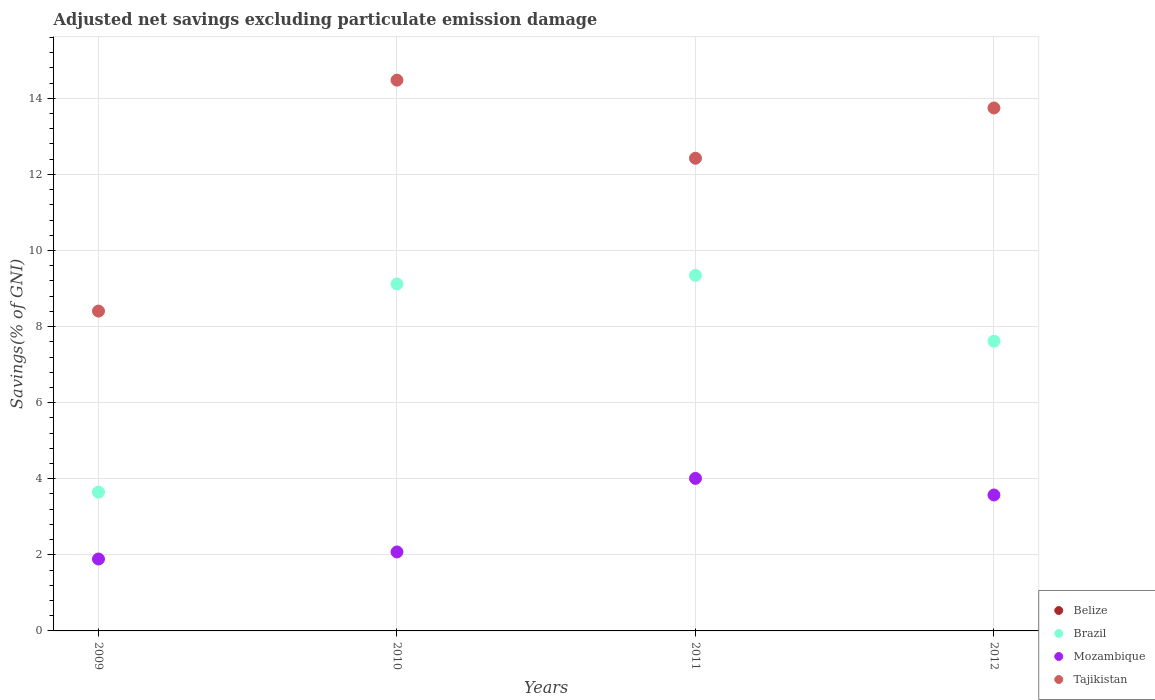How many different coloured dotlines are there?
Offer a terse response. 3. Is the number of dotlines equal to the number of legend labels?
Provide a succinct answer. No. Across all years, what is the maximum adjusted net savings in Tajikistan?
Provide a short and direct response. 14.48. Across all years, what is the minimum adjusted net savings in Mozambique?
Keep it short and to the point. 1.89. In which year was the adjusted net savings in Brazil maximum?
Your answer should be very brief. 2011. What is the total adjusted net savings in Belize in the graph?
Offer a terse response. 0. What is the difference between the adjusted net savings in Mozambique in 2010 and that in 2011?
Offer a terse response. -1.93. What is the difference between the adjusted net savings in Tajikistan in 2011 and the adjusted net savings in Brazil in 2010?
Make the answer very short. 3.3. What is the average adjusted net savings in Tajikistan per year?
Keep it short and to the point. 12.26. In the year 2012, what is the difference between the adjusted net savings in Tajikistan and adjusted net savings in Brazil?
Your answer should be very brief. 6.13. What is the ratio of the adjusted net savings in Brazil in 2010 to that in 2012?
Ensure brevity in your answer.  1.2. What is the difference between the highest and the second highest adjusted net savings in Mozambique?
Provide a short and direct response. 0.44. What is the difference between the highest and the lowest adjusted net savings in Tajikistan?
Offer a very short reply. 6.07. In how many years, is the adjusted net savings in Mozambique greater than the average adjusted net savings in Mozambique taken over all years?
Provide a short and direct response. 2. Is the sum of the adjusted net savings in Brazil in 2010 and 2012 greater than the maximum adjusted net savings in Belize across all years?
Provide a short and direct response. Yes. Is it the case that in every year, the sum of the adjusted net savings in Brazil and adjusted net savings in Mozambique  is greater than the adjusted net savings in Belize?
Offer a terse response. Yes. Is the adjusted net savings in Tajikistan strictly greater than the adjusted net savings in Brazil over the years?
Offer a terse response. Yes. Is the adjusted net savings in Tajikistan strictly less than the adjusted net savings in Brazil over the years?
Provide a short and direct response. No. How many dotlines are there?
Provide a succinct answer. 3. What is the difference between two consecutive major ticks on the Y-axis?
Offer a very short reply. 2. Are the values on the major ticks of Y-axis written in scientific E-notation?
Offer a very short reply. No. Does the graph contain grids?
Make the answer very short. Yes. Where does the legend appear in the graph?
Give a very brief answer. Bottom right. How are the legend labels stacked?
Offer a very short reply. Vertical. What is the title of the graph?
Your response must be concise. Adjusted net savings excluding particulate emission damage. What is the label or title of the Y-axis?
Ensure brevity in your answer.  Savings(% of GNI). What is the Savings(% of GNI) in Brazil in 2009?
Offer a terse response. 3.65. What is the Savings(% of GNI) of Mozambique in 2009?
Make the answer very short. 1.89. What is the Savings(% of GNI) in Tajikistan in 2009?
Your answer should be compact. 8.41. What is the Savings(% of GNI) in Belize in 2010?
Ensure brevity in your answer.  0. What is the Savings(% of GNI) in Brazil in 2010?
Your answer should be compact. 9.12. What is the Savings(% of GNI) of Mozambique in 2010?
Your response must be concise. 2.08. What is the Savings(% of GNI) in Tajikistan in 2010?
Provide a short and direct response. 14.48. What is the Savings(% of GNI) of Brazil in 2011?
Your answer should be very brief. 9.35. What is the Savings(% of GNI) in Mozambique in 2011?
Offer a terse response. 4.01. What is the Savings(% of GNI) in Tajikistan in 2011?
Your response must be concise. 12.42. What is the Savings(% of GNI) in Belize in 2012?
Give a very brief answer. 0. What is the Savings(% of GNI) in Brazil in 2012?
Provide a short and direct response. 7.62. What is the Savings(% of GNI) in Mozambique in 2012?
Ensure brevity in your answer.  3.57. What is the Savings(% of GNI) in Tajikistan in 2012?
Your response must be concise. 13.75. Across all years, what is the maximum Savings(% of GNI) in Brazil?
Keep it short and to the point. 9.35. Across all years, what is the maximum Savings(% of GNI) of Mozambique?
Provide a succinct answer. 4.01. Across all years, what is the maximum Savings(% of GNI) in Tajikistan?
Offer a terse response. 14.48. Across all years, what is the minimum Savings(% of GNI) of Brazil?
Offer a terse response. 3.65. Across all years, what is the minimum Savings(% of GNI) of Mozambique?
Offer a very short reply. 1.89. Across all years, what is the minimum Savings(% of GNI) in Tajikistan?
Your answer should be very brief. 8.41. What is the total Savings(% of GNI) in Belize in the graph?
Provide a succinct answer. 0. What is the total Savings(% of GNI) in Brazil in the graph?
Give a very brief answer. 29.73. What is the total Savings(% of GNI) in Mozambique in the graph?
Offer a terse response. 11.55. What is the total Savings(% of GNI) in Tajikistan in the graph?
Provide a short and direct response. 49.06. What is the difference between the Savings(% of GNI) in Brazil in 2009 and that in 2010?
Provide a short and direct response. -5.47. What is the difference between the Savings(% of GNI) in Mozambique in 2009 and that in 2010?
Give a very brief answer. -0.19. What is the difference between the Savings(% of GNI) of Tajikistan in 2009 and that in 2010?
Give a very brief answer. -6.07. What is the difference between the Savings(% of GNI) in Brazil in 2009 and that in 2011?
Ensure brevity in your answer.  -5.7. What is the difference between the Savings(% of GNI) in Mozambique in 2009 and that in 2011?
Offer a very short reply. -2.12. What is the difference between the Savings(% of GNI) of Tajikistan in 2009 and that in 2011?
Give a very brief answer. -4.02. What is the difference between the Savings(% of GNI) in Brazil in 2009 and that in 2012?
Your answer should be very brief. -3.97. What is the difference between the Savings(% of GNI) in Mozambique in 2009 and that in 2012?
Ensure brevity in your answer.  -1.68. What is the difference between the Savings(% of GNI) in Tajikistan in 2009 and that in 2012?
Your response must be concise. -5.34. What is the difference between the Savings(% of GNI) of Brazil in 2010 and that in 2011?
Offer a very short reply. -0.23. What is the difference between the Savings(% of GNI) of Mozambique in 2010 and that in 2011?
Provide a succinct answer. -1.93. What is the difference between the Savings(% of GNI) in Tajikistan in 2010 and that in 2011?
Keep it short and to the point. 2.05. What is the difference between the Savings(% of GNI) in Brazil in 2010 and that in 2012?
Make the answer very short. 1.51. What is the difference between the Savings(% of GNI) of Mozambique in 2010 and that in 2012?
Your response must be concise. -1.5. What is the difference between the Savings(% of GNI) of Tajikistan in 2010 and that in 2012?
Offer a very short reply. 0.73. What is the difference between the Savings(% of GNI) of Brazil in 2011 and that in 2012?
Provide a short and direct response. 1.73. What is the difference between the Savings(% of GNI) in Mozambique in 2011 and that in 2012?
Your response must be concise. 0.44. What is the difference between the Savings(% of GNI) of Tajikistan in 2011 and that in 2012?
Give a very brief answer. -1.32. What is the difference between the Savings(% of GNI) of Brazil in 2009 and the Savings(% of GNI) of Mozambique in 2010?
Your answer should be compact. 1.57. What is the difference between the Savings(% of GNI) in Brazil in 2009 and the Savings(% of GNI) in Tajikistan in 2010?
Keep it short and to the point. -10.83. What is the difference between the Savings(% of GNI) of Mozambique in 2009 and the Savings(% of GNI) of Tajikistan in 2010?
Your answer should be very brief. -12.59. What is the difference between the Savings(% of GNI) in Brazil in 2009 and the Savings(% of GNI) in Mozambique in 2011?
Offer a very short reply. -0.36. What is the difference between the Savings(% of GNI) in Brazil in 2009 and the Savings(% of GNI) in Tajikistan in 2011?
Your response must be concise. -8.78. What is the difference between the Savings(% of GNI) in Mozambique in 2009 and the Savings(% of GNI) in Tajikistan in 2011?
Offer a very short reply. -10.53. What is the difference between the Savings(% of GNI) in Brazil in 2009 and the Savings(% of GNI) in Mozambique in 2012?
Offer a terse response. 0.07. What is the difference between the Savings(% of GNI) in Brazil in 2009 and the Savings(% of GNI) in Tajikistan in 2012?
Make the answer very short. -10.1. What is the difference between the Savings(% of GNI) of Mozambique in 2009 and the Savings(% of GNI) of Tajikistan in 2012?
Provide a succinct answer. -11.86. What is the difference between the Savings(% of GNI) in Brazil in 2010 and the Savings(% of GNI) in Mozambique in 2011?
Offer a very short reply. 5.11. What is the difference between the Savings(% of GNI) in Brazil in 2010 and the Savings(% of GNI) in Tajikistan in 2011?
Your response must be concise. -3.3. What is the difference between the Savings(% of GNI) of Mozambique in 2010 and the Savings(% of GNI) of Tajikistan in 2011?
Provide a succinct answer. -10.35. What is the difference between the Savings(% of GNI) of Brazil in 2010 and the Savings(% of GNI) of Mozambique in 2012?
Your answer should be compact. 5.55. What is the difference between the Savings(% of GNI) of Brazil in 2010 and the Savings(% of GNI) of Tajikistan in 2012?
Make the answer very short. -4.63. What is the difference between the Savings(% of GNI) in Mozambique in 2010 and the Savings(% of GNI) in Tajikistan in 2012?
Your answer should be compact. -11.67. What is the difference between the Savings(% of GNI) of Brazil in 2011 and the Savings(% of GNI) of Mozambique in 2012?
Ensure brevity in your answer.  5.77. What is the difference between the Savings(% of GNI) in Brazil in 2011 and the Savings(% of GNI) in Tajikistan in 2012?
Your response must be concise. -4.4. What is the difference between the Savings(% of GNI) of Mozambique in 2011 and the Savings(% of GNI) of Tajikistan in 2012?
Give a very brief answer. -9.74. What is the average Savings(% of GNI) in Brazil per year?
Provide a succinct answer. 7.43. What is the average Savings(% of GNI) in Mozambique per year?
Offer a terse response. 2.89. What is the average Savings(% of GNI) of Tajikistan per year?
Your answer should be compact. 12.26. In the year 2009, what is the difference between the Savings(% of GNI) in Brazil and Savings(% of GNI) in Mozambique?
Your answer should be compact. 1.76. In the year 2009, what is the difference between the Savings(% of GNI) in Brazil and Savings(% of GNI) in Tajikistan?
Your answer should be compact. -4.76. In the year 2009, what is the difference between the Savings(% of GNI) in Mozambique and Savings(% of GNI) in Tajikistan?
Ensure brevity in your answer.  -6.52. In the year 2010, what is the difference between the Savings(% of GNI) of Brazil and Savings(% of GNI) of Mozambique?
Keep it short and to the point. 7.04. In the year 2010, what is the difference between the Savings(% of GNI) of Brazil and Savings(% of GNI) of Tajikistan?
Provide a succinct answer. -5.36. In the year 2010, what is the difference between the Savings(% of GNI) of Mozambique and Savings(% of GNI) of Tajikistan?
Your response must be concise. -12.4. In the year 2011, what is the difference between the Savings(% of GNI) of Brazil and Savings(% of GNI) of Mozambique?
Your response must be concise. 5.34. In the year 2011, what is the difference between the Savings(% of GNI) of Brazil and Savings(% of GNI) of Tajikistan?
Offer a very short reply. -3.08. In the year 2011, what is the difference between the Savings(% of GNI) of Mozambique and Savings(% of GNI) of Tajikistan?
Provide a succinct answer. -8.42. In the year 2012, what is the difference between the Savings(% of GNI) in Brazil and Savings(% of GNI) in Mozambique?
Your response must be concise. 4.04. In the year 2012, what is the difference between the Savings(% of GNI) in Brazil and Savings(% of GNI) in Tajikistan?
Provide a succinct answer. -6.13. In the year 2012, what is the difference between the Savings(% of GNI) of Mozambique and Savings(% of GNI) of Tajikistan?
Keep it short and to the point. -10.17. What is the ratio of the Savings(% of GNI) in Mozambique in 2009 to that in 2010?
Make the answer very short. 0.91. What is the ratio of the Savings(% of GNI) in Tajikistan in 2009 to that in 2010?
Keep it short and to the point. 0.58. What is the ratio of the Savings(% of GNI) of Brazil in 2009 to that in 2011?
Ensure brevity in your answer.  0.39. What is the ratio of the Savings(% of GNI) in Mozambique in 2009 to that in 2011?
Give a very brief answer. 0.47. What is the ratio of the Savings(% of GNI) in Tajikistan in 2009 to that in 2011?
Ensure brevity in your answer.  0.68. What is the ratio of the Savings(% of GNI) in Brazil in 2009 to that in 2012?
Provide a succinct answer. 0.48. What is the ratio of the Savings(% of GNI) of Mozambique in 2009 to that in 2012?
Your answer should be very brief. 0.53. What is the ratio of the Savings(% of GNI) in Tajikistan in 2009 to that in 2012?
Give a very brief answer. 0.61. What is the ratio of the Savings(% of GNI) of Brazil in 2010 to that in 2011?
Offer a terse response. 0.98. What is the ratio of the Savings(% of GNI) of Mozambique in 2010 to that in 2011?
Provide a short and direct response. 0.52. What is the ratio of the Savings(% of GNI) in Tajikistan in 2010 to that in 2011?
Offer a terse response. 1.17. What is the ratio of the Savings(% of GNI) in Brazil in 2010 to that in 2012?
Ensure brevity in your answer.  1.2. What is the ratio of the Savings(% of GNI) in Mozambique in 2010 to that in 2012?
Provide a short and direct response. 0.58. What is the ratio of the Savings(% of GNI) of Tajikistan in 2010 to that in 2012?
Offer a terse response. 1.05. What is the ratio of the Savings(% of GNI) in Brazil in 2011 to that in 2012?
Provide a short and direct response. 1.23. What is the ratio of the Savings(% of GNI) in Mozambique in 2011 to that in 2012?
Your answer should be compact. 1.12. What is the ratio of the Savings(% of GNI) in Tajikistan in 2011 to that in 2012?
Ensure brevity in your answer.  0.9. What is the difference between the highest and the second highest Savings(% of GNI) of Brazil?
Make the answer very short. 0.23. What is the difference between the highest and the second highest Savings(% of GNI) of Mozambique?
Offer a very short reply. 0.44. What is the difference between the highest and the second highest Savings(% of GNI) of Tajikistan?
Your answer should be very brief. 0.73. What is the difference between the highest and the lowest Savings(% of GNI) in Brazil?
Your answer should be compact. 5.7. What is the difference between the highest and the lowest Savings(% of GNI) of Mozambique?
Offer a very short reply. 2.12. What is the difference between the highest and the lowest Savings(% of GNI) of Tajikistan?
Keep it short and to the point. 6.07. 